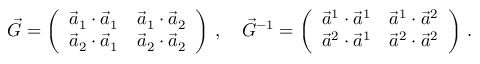Convert formula to latex. <formula><loc_0><loc_0><loc_500><loc_500>\vec { G } = \left ( \begin{array} { l l } { \vec { a } _ { 1 } \cdot \vec { a } _ { 1 } } & { \vec { a } _ { 1 } \cdot \vec { a } _ { 2 } } \\ { \vec { a } _ { 2 } \cdot \vec { a } _ { 1 } } & { \vec { a } _ { 2 } \cdot \vec { a } _ { 2 } } \end{array} \right ) \, , \quad \vec { G } ^ { - 1 } = \left ( \begin{array} { l l } { \vec { a } ^ { 1 } \cdot \vec { a } ^ { 1 } } & { \vec { a } ^ { 1 } \cdot \vec { a } ^ { 2 } } \\ { \vec { a } ^ { 2 } \cdot \vec { a } ^ { 1 } } & { \vec { a } ^ { 2 } \cdot \vec { a } ^ { 2 } } \end{array} \right ) \, .</formula> 